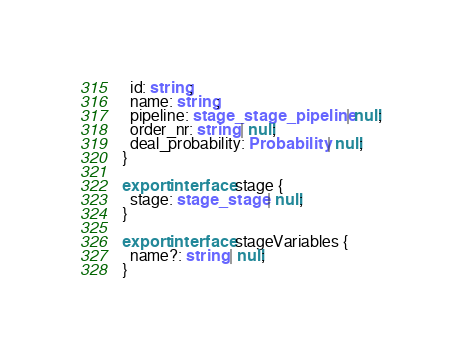<code> <loc_0><loc_0><loc_500><loc_500><_TypeScript_>  id: string;
  name: string;
  pipeline: stage_stage_pipeline | null;
  order_nr: string | null;
  deal_probability: Probability | null;
}

export interface stage {
  stage: stage_stage | null;
}

export interface stageVariables {
  name?: string | null;
}
</code> 